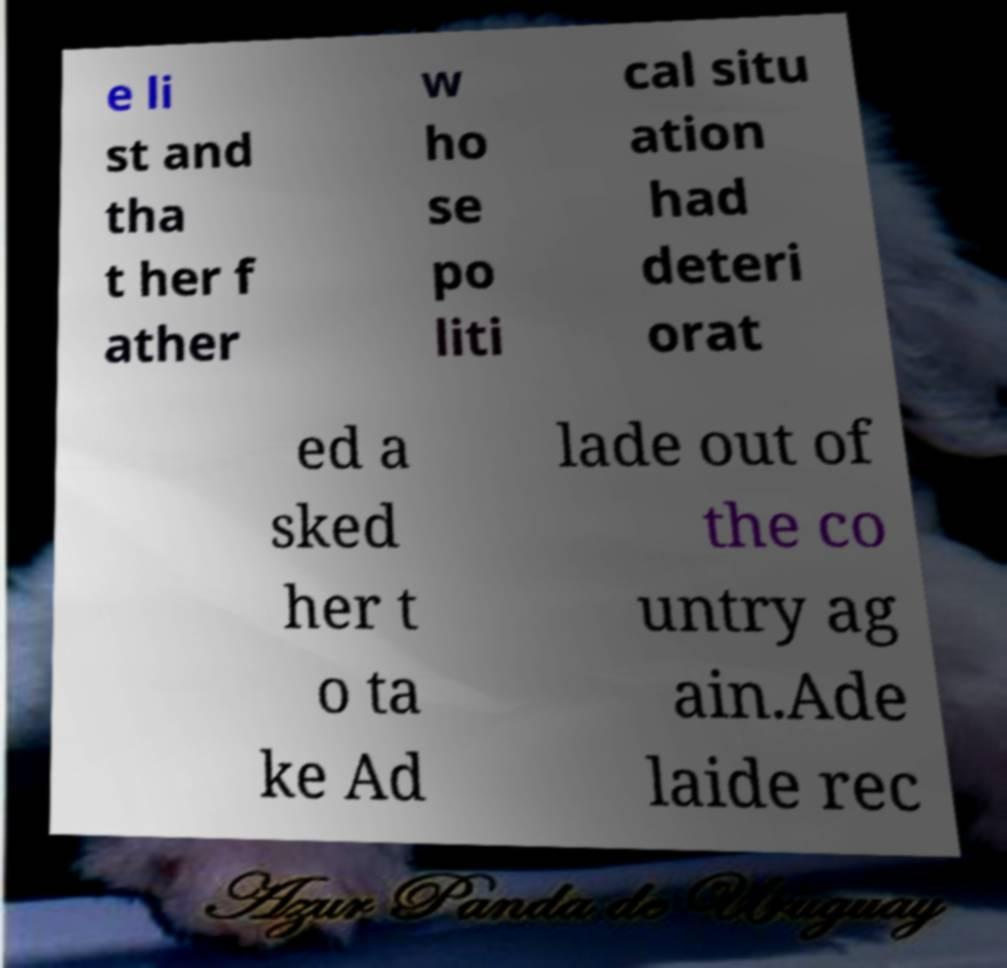Please read and relay the text visible in this image. What does it say? e li st and tha t her f ather w ho se po liti cal situ ation had deteri orat ed a sked her t o ta ke Ad lade out of the co untry ag ain.Ade laide rec 